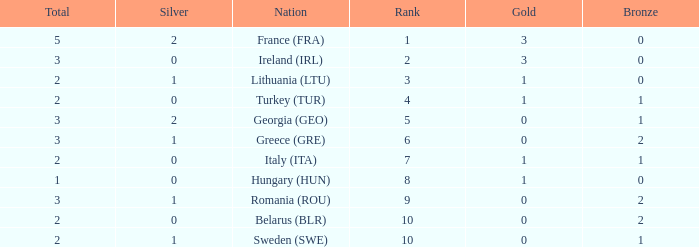What's the total when the gold is less than 0 and silver is less than 1? None. 